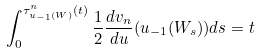<formula> <loc_0><loc_0><loc_500><loc_500>\int ^ { \tau ^ { n } _ { u _ { - 1 } ( W ) } ( t ) } _ { 0 } \frac { 1 } { 2 } \frac { d v _ { n } } { d u } ( u _ { - 1 } ( W _ { s } ) ) d s = t</formula> 